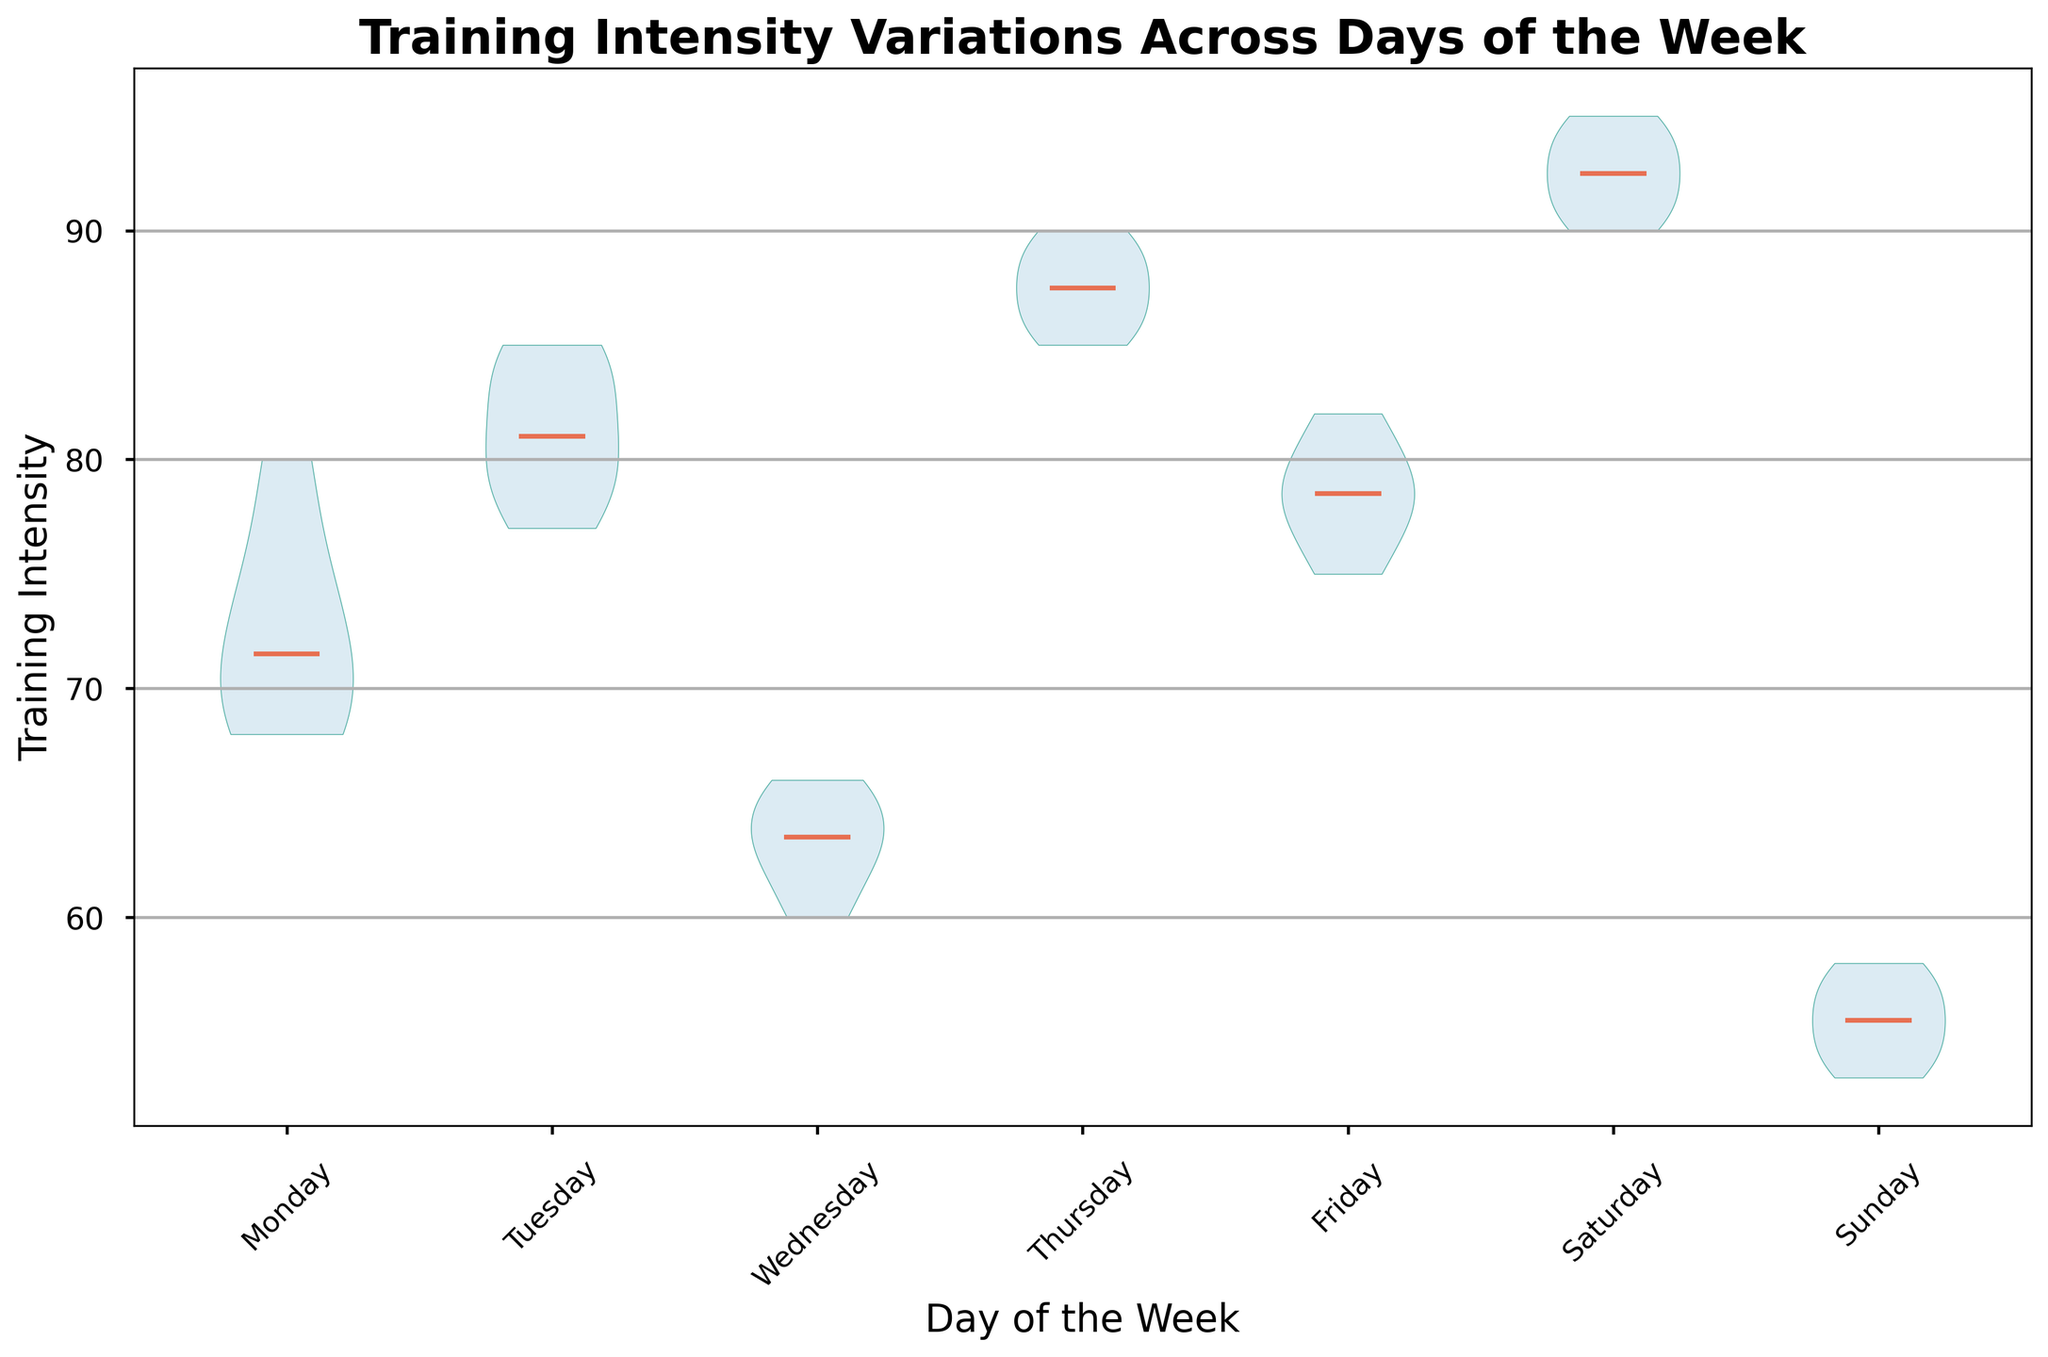What day has the highest median training intensity? By looking at the plot, identify the day where the thick horizontal line in the middle of the violins (representing the median) is the highest. From the plot, this is Saturday.
Answer: Saturday What day shows the lowest training intensity variation? Identify the day where the violin plot is the thinnest, indicating the least variation or spread in the data. This appears to be Sunday.
Answer: Sunday On which day is the training intensity the most consistent, judging by the narrowest violin plot? Consistent training intensity would mean the narrowest spread in the violin plot. The narrowest plot is observed on Sunday.
Answer: Sunday Compare the median training intensity of Tuesday and Wednesday. Which day is higher? Find the median lines for both Tuesday and Wednesday on the plot. Tuesday's median is higher than Wednesday's.
Answer: Tuesday How does the training intensity on Friday compare to that on Monday in terms of spread and median? The median for Friday and Monday can be compared by looking at the horizontal lines. The spread can be compared by examining the width of the violin plots. Friday has a higher median and a wider spread compared to Monday.
Answer: Friday has a higher median and wider spread Which days exhibit bimodal distributions in training intensity? Identify violin plots that exhibit two peaks. This suggests bimodal distribution. From the plot, no clear bimodal distributions are evident; each violin plot appears fairly centered around their medians without multiple peaks.
Answer: None What is the approximate median training intensity for Saturday? Locate the thick horizontal line in the middle of the Saturday violin plot. This line appears around 93.
Answer: 93 Rank the days from highest to lowest based on their median training intensity. Examine the median lines across all the days and rank them from highest to lowest as follows: Saturday, Thursday, Tuesday, Friday, Monday, Wednesday, Sunday.
Answer: Saturday, Thursday, Tuesday, Friday, Monday, Wednesday, Sunday On which days do athletes have a median training intensity above 80? Identify the days where the median (thick horizontal line) is above 80. These days are Tuesday, Thursday, and Saturday.
Answer: Tuesday, Thursday, Saturday Is there any day where the training intensity falls significantly lower than the rest of the week? By looking at the overall distribution and medians, Sunday stands out as having consistently lower training intensity compared to other days.
Answer: Sunday 